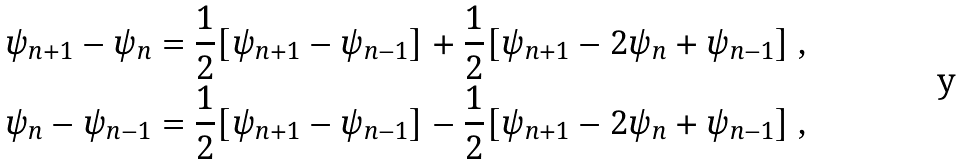<formula> <loc_0><loc_0><loc_500><loc_500>& \psi _ { n + 1 } - \psi _ { n } = \frac { 1 } { 2 } [ \psi _ { n + 1 } - \psi _ { n - 1 } ] + \frac { 1 } { 2 } [ \psi _ { n + 1 } - 2 \psi _ { n } + \psi _ { n - 1 } ] \ , \\ & \psi _ { n } - \psi _ { n - 1 } = \frac { 1 } { 2 } [ \psi _ { n + 1 } - \psi _ { n - 1 } ] - \frac { 1 } { 2 } [ \psi _ { n + 1 } - 2 \psi _ { n } + \psi _ { n - 1 } ] \ ,</formula> 